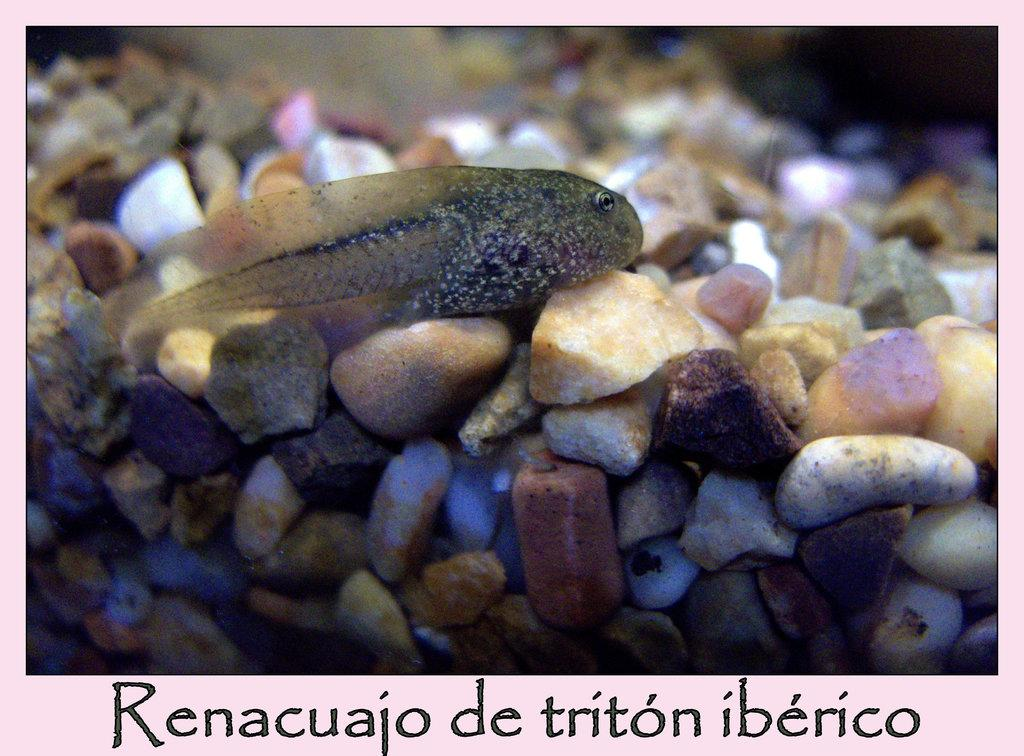What type of animal is in the image? There is a fish in the image. What else can be seen in the image besides the fish? There are stones in the image. Is there any text present in the image? Yes, there is text at the bottom of the image. Where is the seed located in the image? There is no seed present in the image. Is the text in the image a work of fiction? We cannot determine if the text in the image is a work of fiction based on the provided facts. 